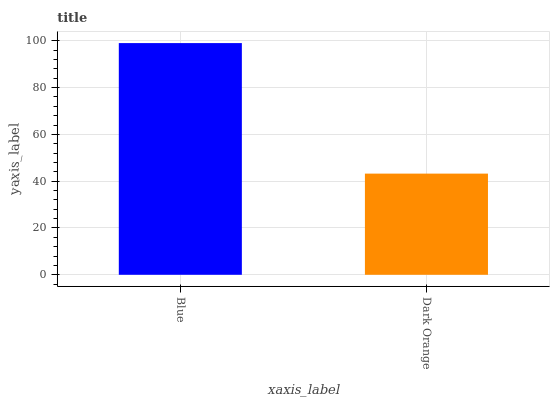Is Dark Orange the minimum?
Answer yes or no. Yes. Is Blue the maximum?
Answer yes or no. Yes. Is Dark Orange the maximum?
Answer yes or no. No. Is Blue greater than Dark Orange?
Answer yes or no. Yes. Is Dark Orange less than Blue?
Answer yes or no. Yes. Is Dark Orange greater than Blue?
Answer yes or no. No. Is Blue less than Dark Orange?
Answer yes or no. No. Is Blue the high median?
Answer yes or no. Yes. Is Dark Orange the low median?
Answer yes or no. Yes. Is Dark Orange the high median?
Answer yes or no. No. Is Blue the low median?
Answer yes or no. No. 